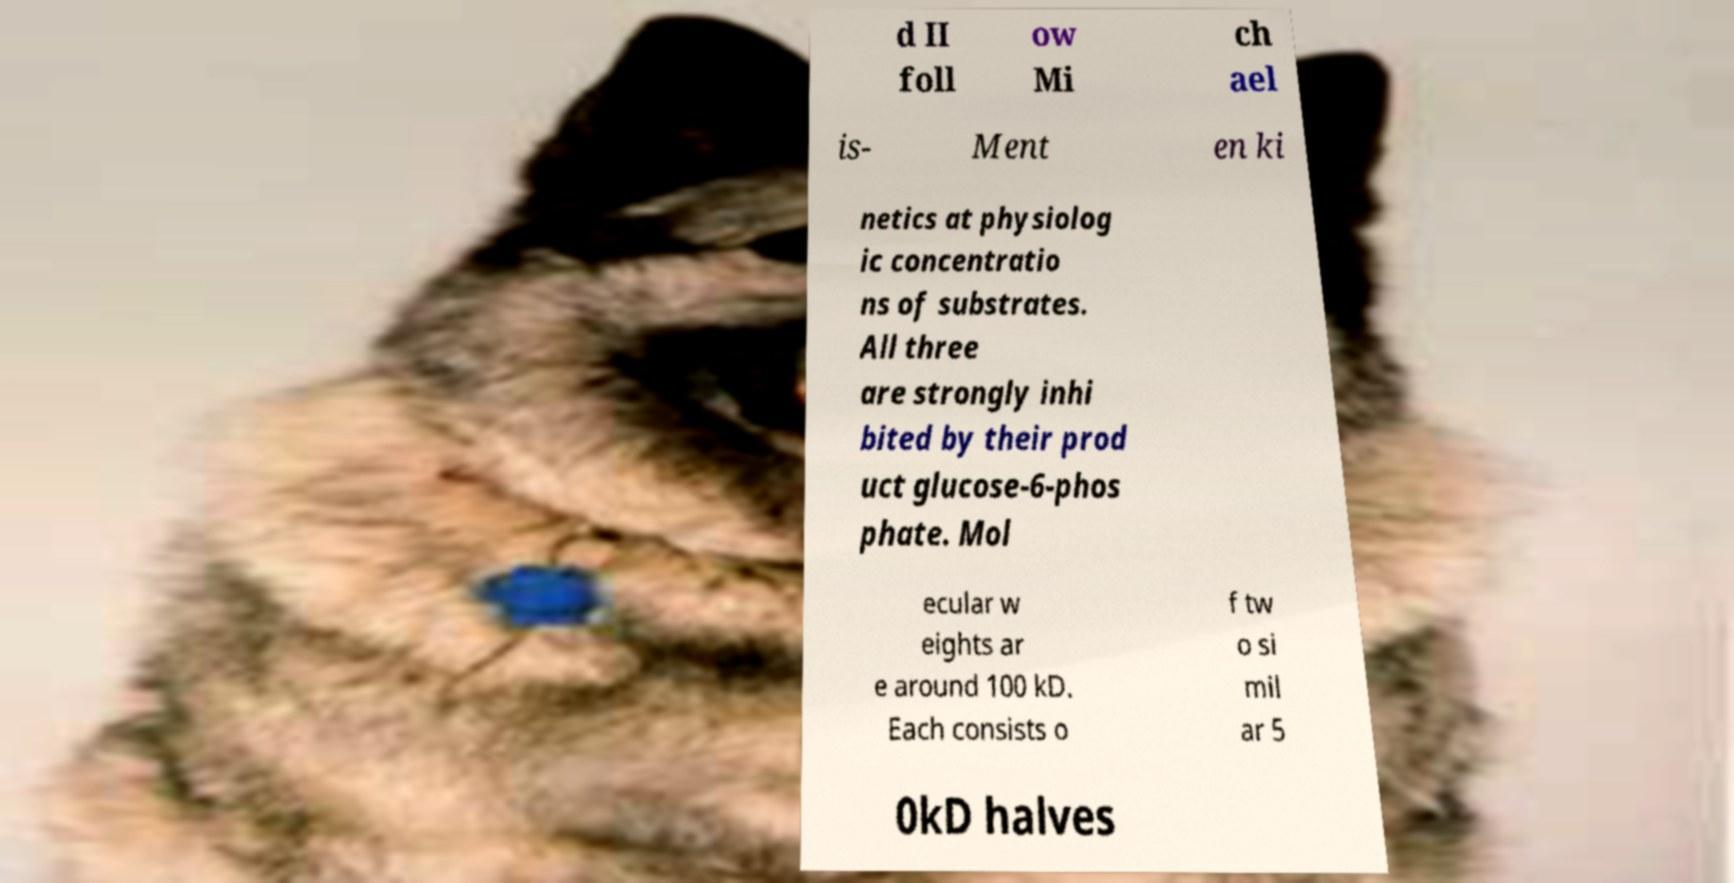Could you extract and type out the text from this image? d II foll ow Mi ch ael is- Ment en ki netics at physiolog ic concentratio ns of substrates. All three are strongly inhi bited by their prod uct glucose-6-phos phate. Mol ecular w eights ar e around 100 kD. Each consists o f tw o si mil ar 5 0kD halves 